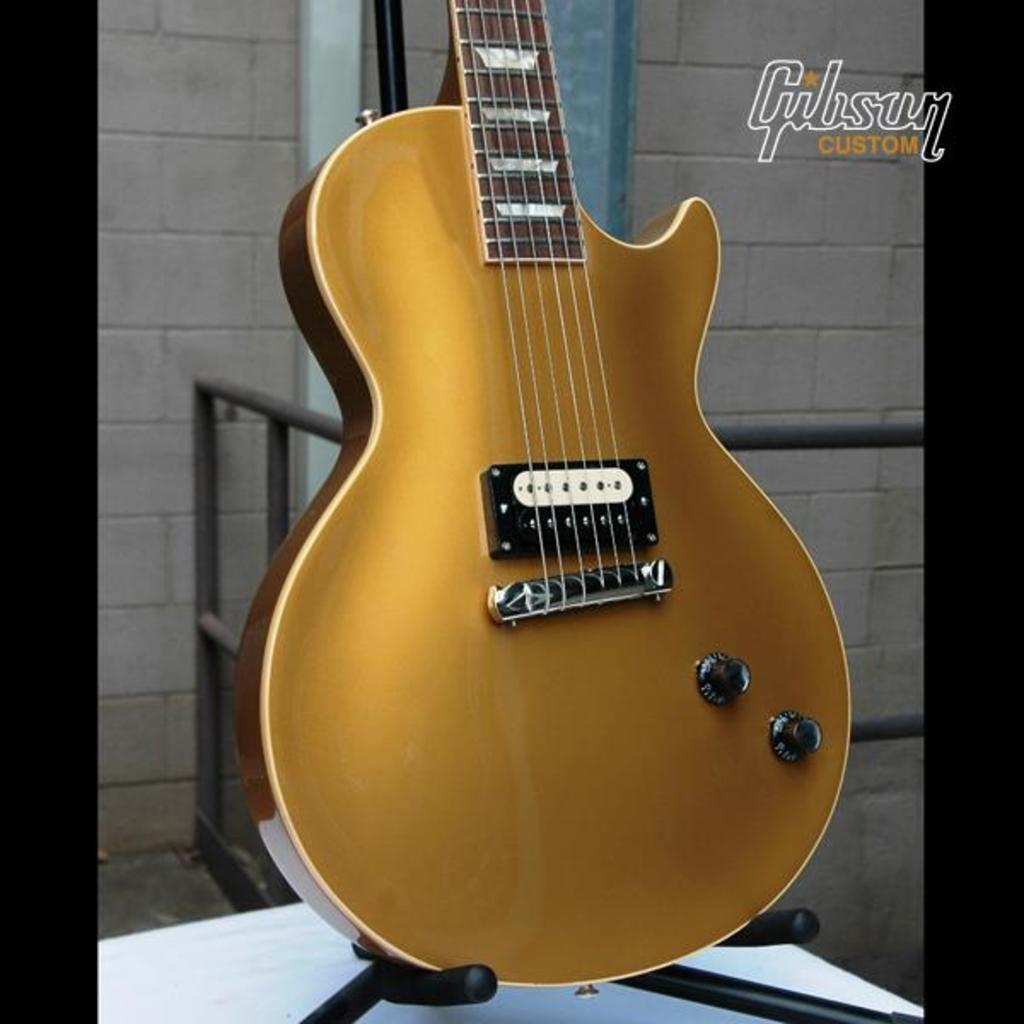What musical instrument is present in the image? There is a guitar in the image. Where is the guitar located in relation to the other elements in the image? The guitar is in the background. What type of structure can be seen in the image? There is a wall in the image. What type of material is used for the rods in the image? The rods in the image are made of metal. What type of account is being discussed in the image? There is no mention of an account in the image; it features a guitar, a wall, and metal rods. What type of meal is being prepared in the image? There is no meal preparation visible in the image; it features a guitar, a wall, and metal rods. 